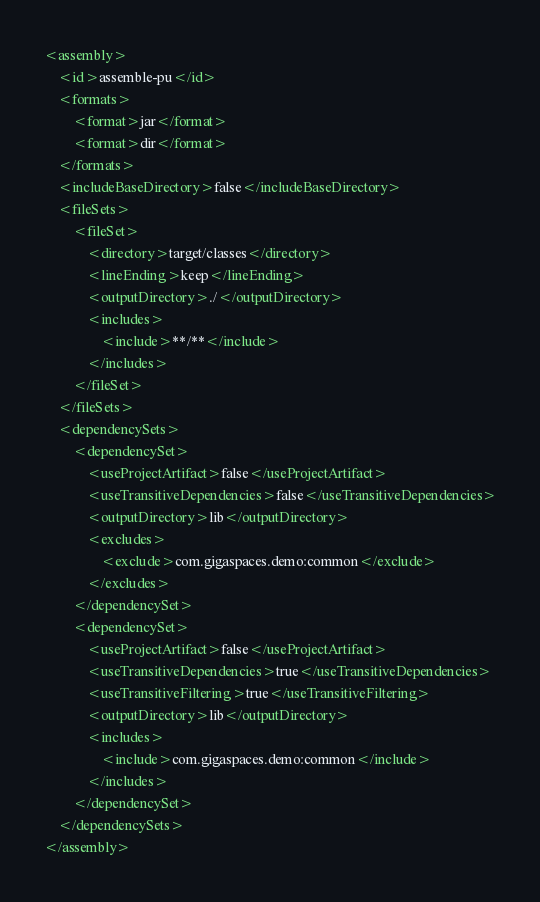<code> <loc_0><loc_0><loc_500><loc_500><_XML_><assembly>
    <id>assemble-pu</id>
    <formats>
        <format>jar</format>
        <format>dir</format>
    </formats>
    <includeBaseDirectory>false</includeBaseDirectory>
    <fileSets>
        <fileSet>
            <directory>target/classes</directory>
            <lineEnding>keep</lineEnding>
            <outputDirectory>./</outputDirectory>
            <includes>
                <include>**/**</include>
            </includes>
        </fileSet>
    </fileSets>
    <dependencySets>
        <dependencySet>
            <useProjectArtifact>false</useProjectArtifact>
            <useTransitiveDependencies>false</useTransitiveDependencies>
            <outputDirectory>lib</outputDirectory>
            <excludes>
                <exclude>com.gigaspaces.demo:common</exclude>
            </excludes>
        </dependencySet>
        <dependencySet>
            <useProjectArtifact>false</useProjectArtifact>
            <useTransitiveDependencies>true</useTransitiveDependencies>
            <useTransitiveFiltering>true</useTransitiveFiltering>
            <outputDirectory>lib</outputDirectory>
            <includes>
                <include>com.gigaspaces.demo:common</include>
            </includes>
        </dependencySet>
    </dependencySets>
</assembly>
</code> 